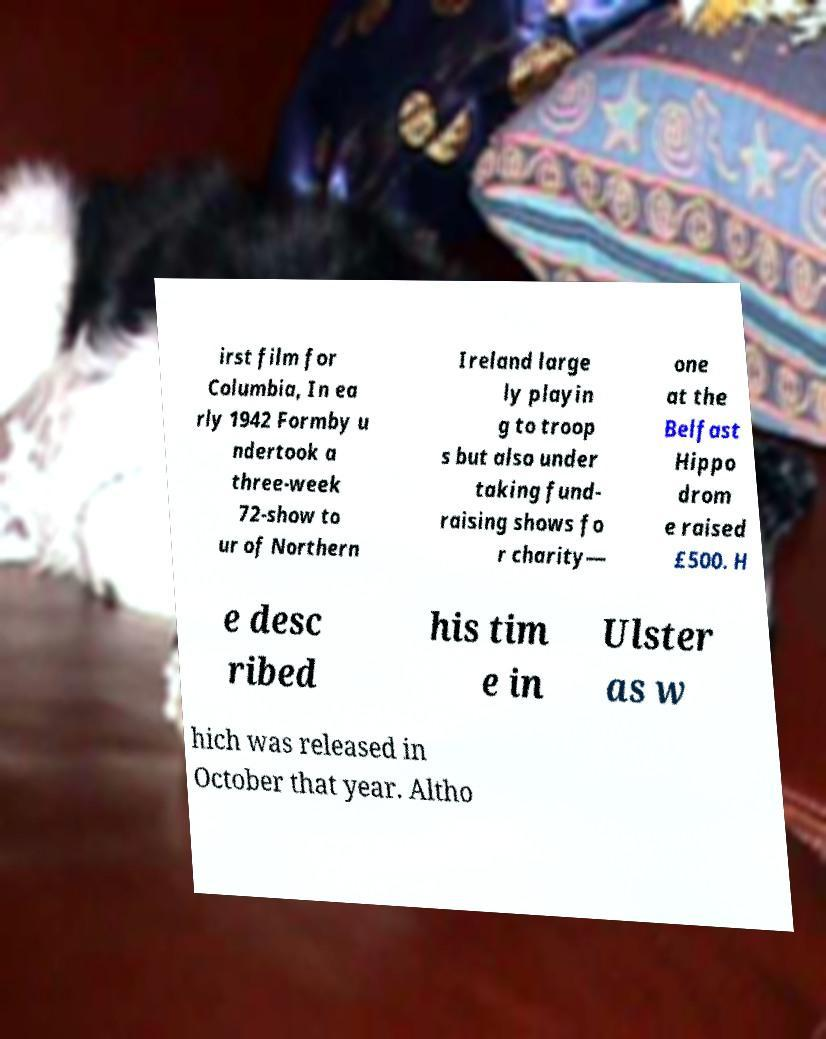For documentation purposes, I need the text within this image transcribed. Could you provide that? irst film for Columbia, In ea rly 1942 Formby u ndertook a three-week 72-show to ur of Northern Ireland large ly playin g to troop s but also under taking fund- raising shows fo r charity— one at the Belfast Hippo drom e raised £500. H e desc ribed his tim e in Ulster as w hich was released in October that year. Altho 